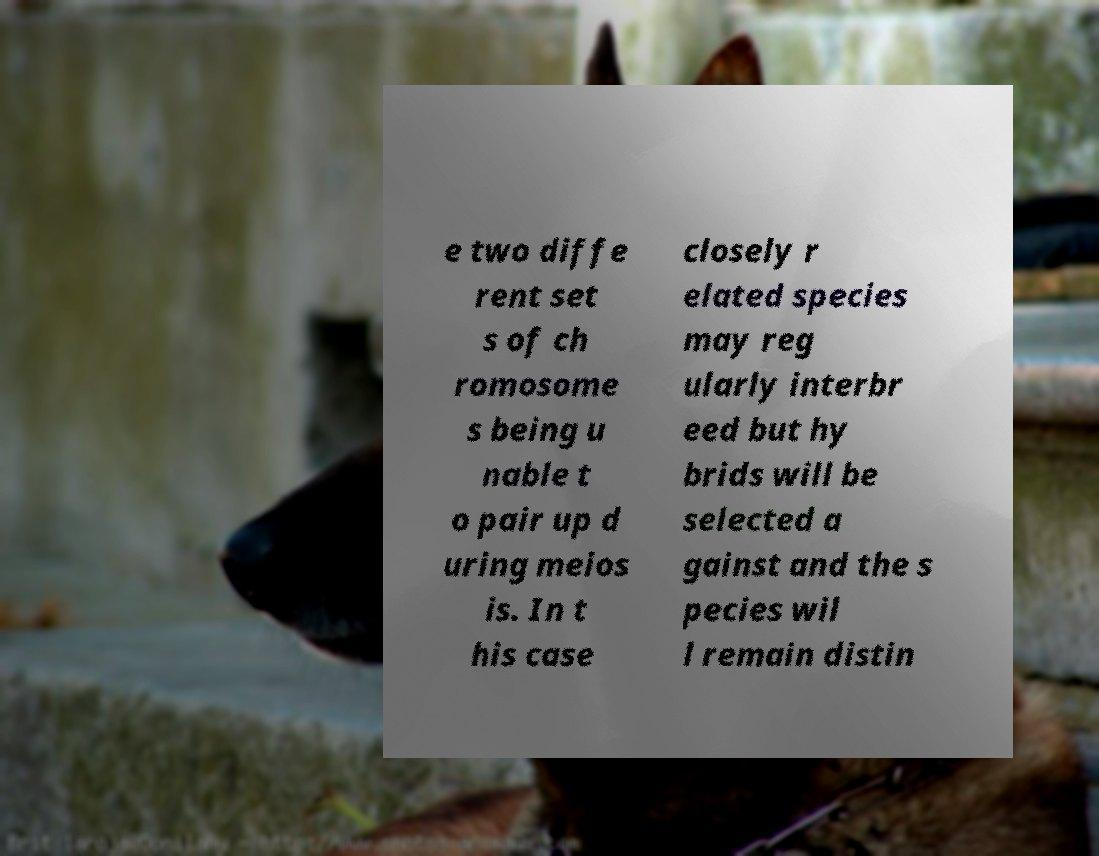I need the written content from this picture converted into text. Can you do that? e two diffe rent set s of ch romosome s being u nable t o pair up d uring meios is. In t his case closely r elated species may reg ularly interbr eed but hy brids will be selected a gainst and the s pecies wil l remain distin 